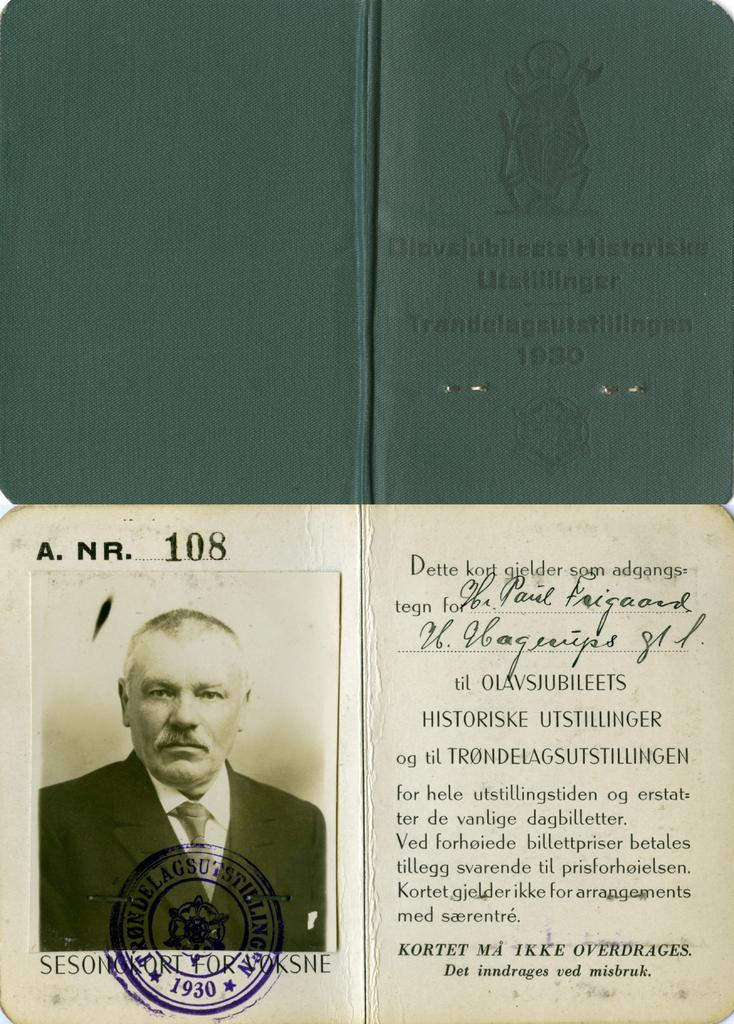<image>
Create a compact narrative representing the image presented. A photo passport of a man that reads Trandelageustillingen. 